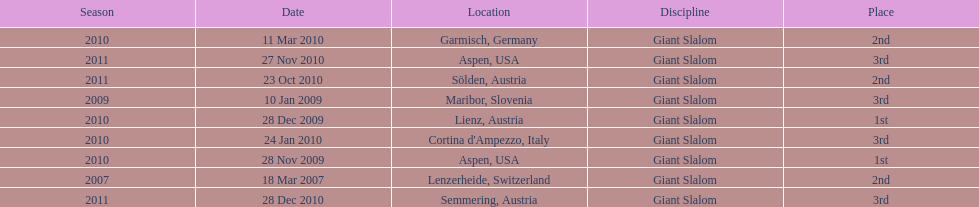How many races were in 2010? 5. 